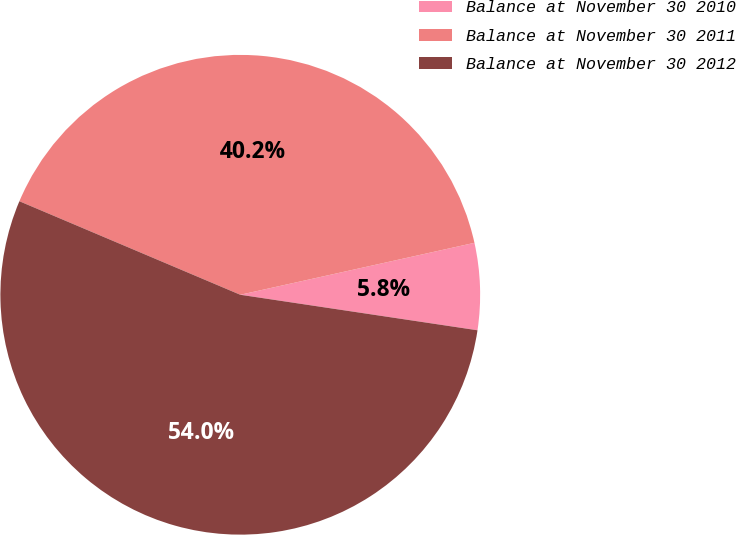Convert chart to OTSL. <chart><loc_0><loc_0><loc_500><loc_500><pie_chart><fcel>Balance at November 30 2010<fcel>Balance at November 30 2011<fcel>Balance at November 30 2012<nl><fcel>5.84%<fcel>40.15%<fcel>54.01%<nl></chart> 